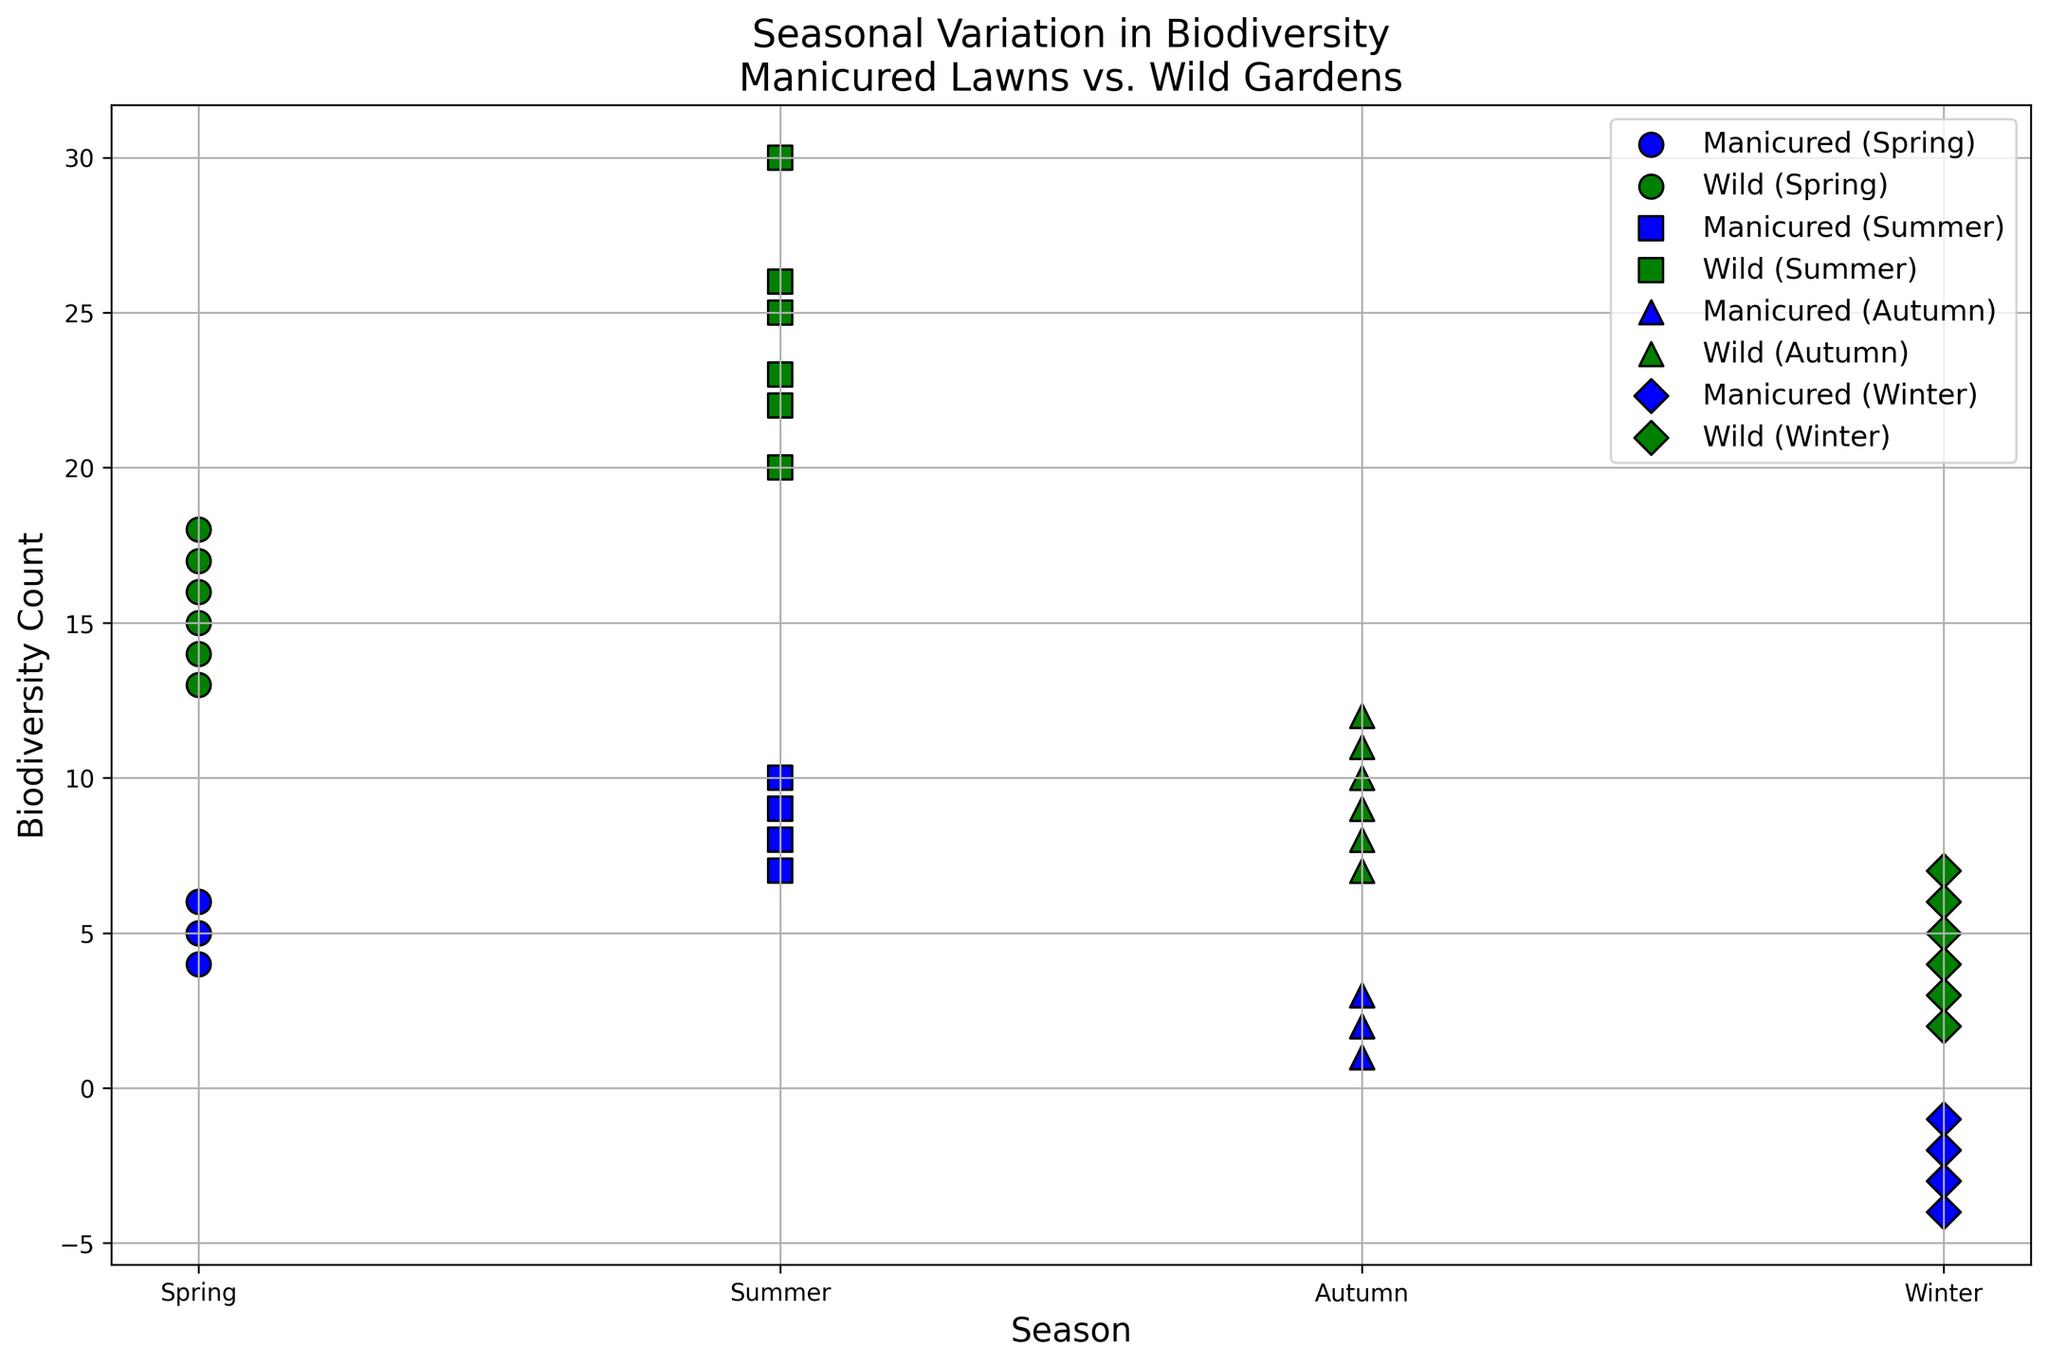What's the total biodiversity count for manicured lawns in Spring across all neighborhoods? To find the total biodiversity count for manicured lawns in Spring, add the biodiversity counts in Spring for each neighborhood: 5 + 6 + 4 + 5 + 6 + 5. This equals 31.
Answer: 31 Which season has the highest biodiversity counts in wild gardens across all neighborhoods? Look at the scatter plot and identify the season with the highest green markers. Summer shows the highest biodiversity counts for wild gardens with values ranging from 20 to 30.
Answer: Summer During Autumn, how does the biodiversity in manicured lawns compare to wild gardens? Compare the blue and green markers for Autumn. Biodiversity counts for manicured lawns in Autumn are considerably lower (1 to 3) than those for wild gardens (7 to 12).
Answer: Lower Are there any seasons where the biodiversity count in manicured lawns is negative? Look at the blue markers to see if any values drop below zero. Winter has negative biodiversity counts for manicured lawns in multiple neighborhoods (-2 to -4).
Answer: Yes, Winter What is the average biodiversity count in wild gardens during Winter across all neighborhoods? Add the biodiversity counts in Winter for wild gardens and divide by the number of neighborhoods: (7 + 5 + 3 + 6 + 4 + 2)/6 = 27/6 = 4.5.
Answer: 4.5 In which season is the difference between manicured lawns and wild gardens biodiversity greatest for Neighborhood 1? Calculate the difference for each season: Spring (15 - 5 = 10), Summer (25 - 8 = 17), Autumn (12 - 3 = 9), Winter (7 - (-2) = 9). The difference is greatest in Summer.
Answer: Summer How does biodiversity in manicured lawns vary seasonally? Observe the blue markers across all seasons. Biodiversity in manicured lawns tends to be highest in Summer, moderate in Spring and Autumn, and lowest (even negative) in Winter.
Answer: Highest in Summer, lowest in Winter Are there any neighborhoods where the biodiversity count for both manicured lawns and wild gardens is positive in every season? Check each neighborhood's scatter points for all seasons to see whether all points are positive. No neighborhood has positive biodiversity counts in both manicured lawns and wild gardens for every season.
Answer: No What visual cue helps to differentiate biodiversity in manicured lawns from wild gardens on the plot? The scatter plot uses different colors: blue for manicured lawns and green for wild gardens. The markers are also used to differentiate various seasons.
Answer: Color and markers 